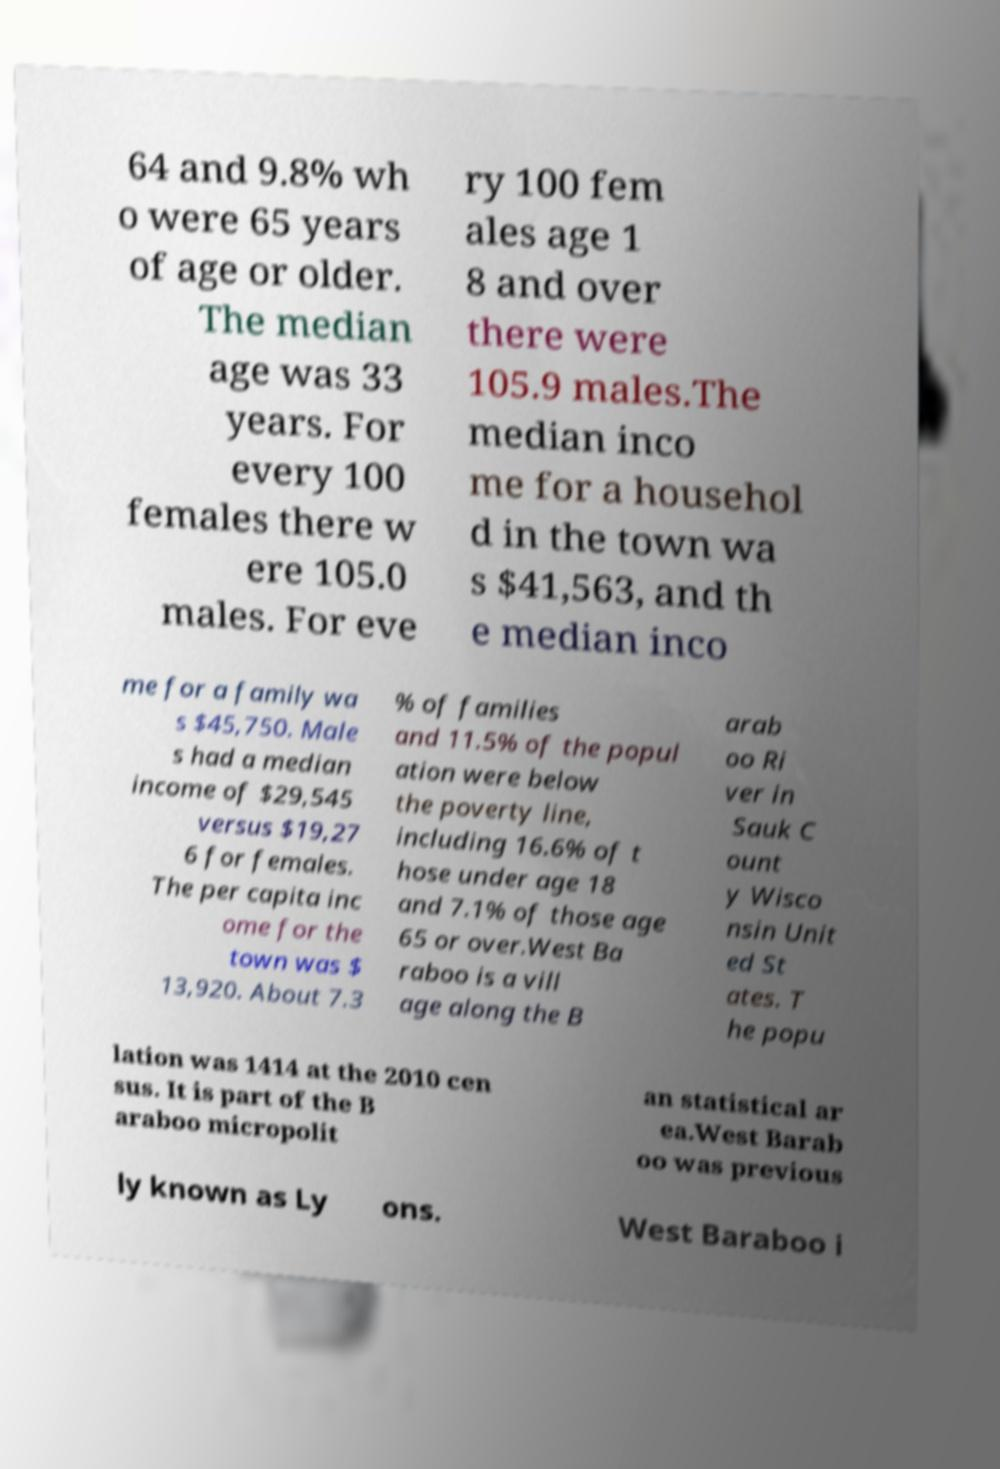I need the written content from this picture converted into text. Can you do that? 64 and 9.8% wh o were 65 years of age or older. The median age was 33 years. For every 100 females there w ere 105.0 males. For eve ry 100 fem ales age 1 8 and over there were 105.9 males.The median inco me for a househol d in the town wa s $41,563, and th e median inco me for a family wa s $45,750. Male s had a median income of $29,545 versus $19,27 6 for females. The per capita inc ome for the town was $ 13,920. About 7.3 % of families and 11.5% of the popul ation were below the poverty line, including 16.6% of t hose under age 18 and 7.1% of those age 65 or over.West Ba raboo is a vill age along the B arab oo Ri ver in Sauk C ount y Wisco nsin Unit ed St ates. T he popu lation was 1414 at the 2010 cen sus. It is part of the B araboo micropolit an statistical ar ea.West Barab oo was previous ly known as Ly ons. West Baraboo i 